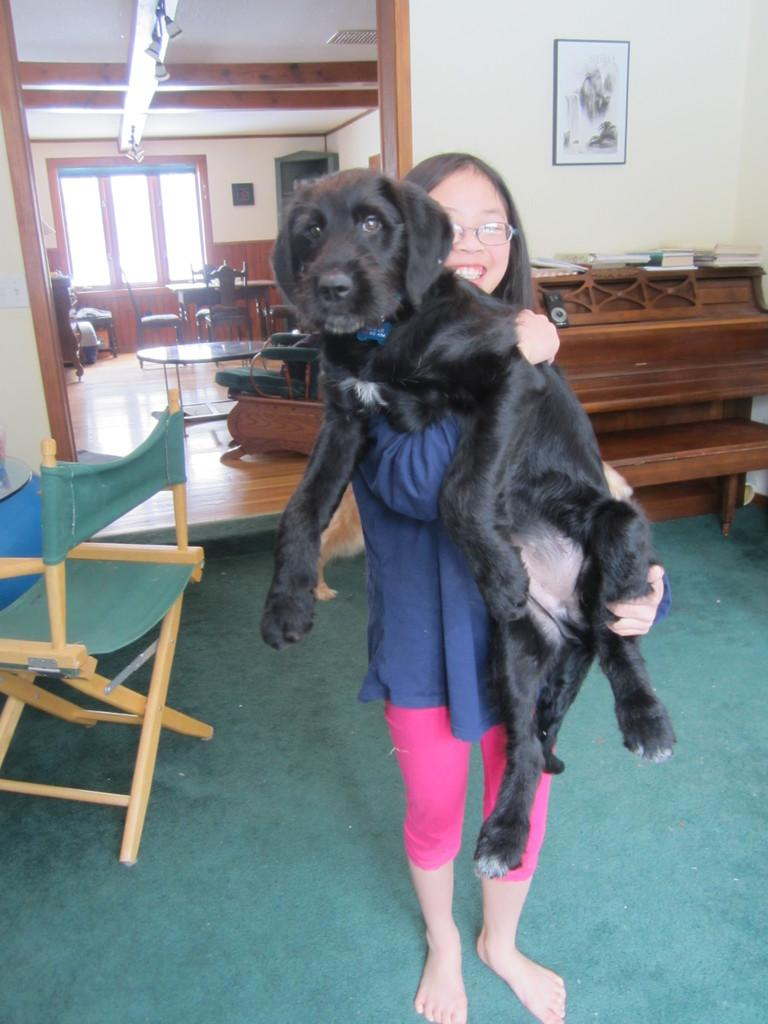What is the main subject of the image? The main subject of the image is a girl. What is the girl doing in the image? The girl is standing in the image. What is the girl holding in the image? The girl is holding a black color dog in the image. What time of day is it in the image, and what type of bushes can be seen in the background? The provided facts do not mention the time of day or any bushes in the background. 